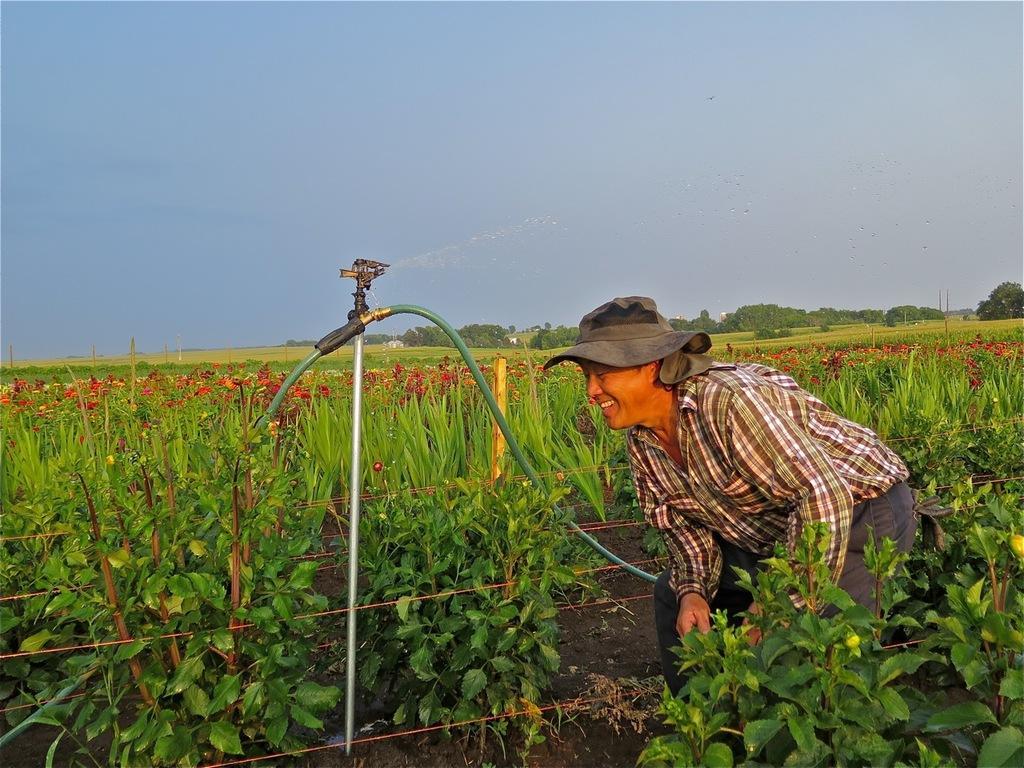Can you describe this image briefly? In this image we can see a man wearing a hat standing on the ground. We can also see a sprinkler on a stand with a pipe connected to it. On the backside we can see a group of plants, a fence, plants with flowers, a group of trees, poles and the sky which looks cloudy. 